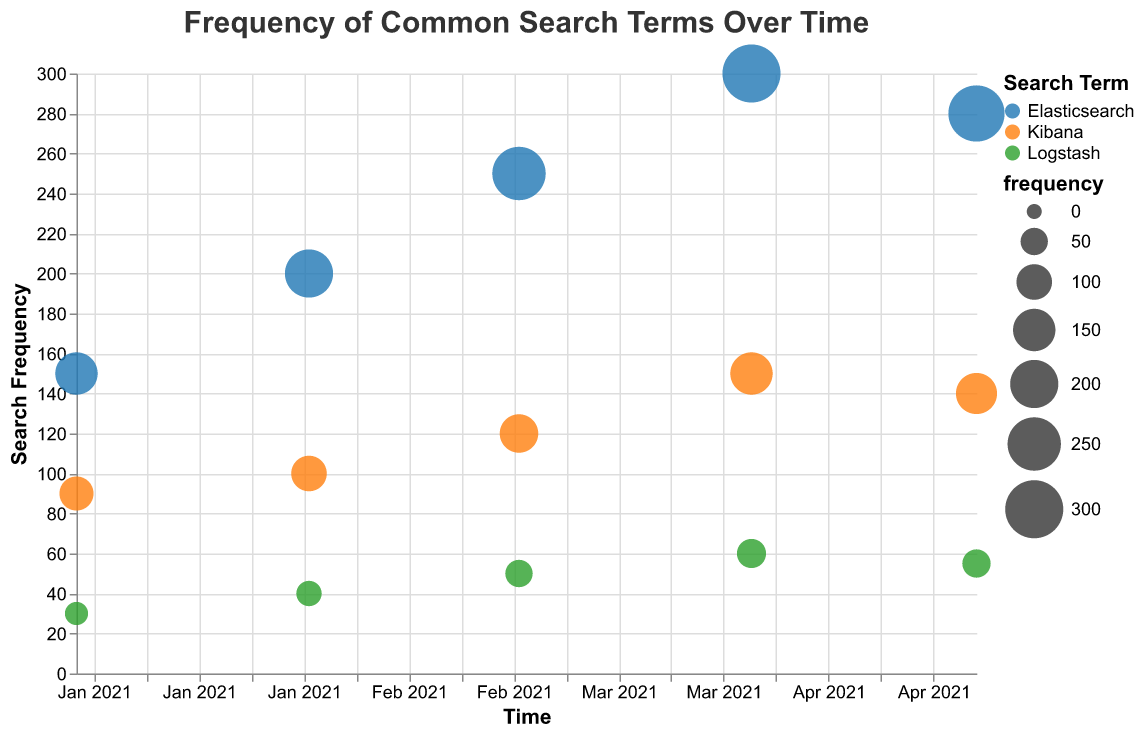What is the title of the figure? The title is located at the top of the figure and clearly labeled. It summarizes the content of the chart.
Answer: Frequency of Common Search Terms Over Time What is the color assigned to the term "Elasticsearch"? The color for each search term is indicated in the legend at the right side of the figure.
Answer: Blue Which search term has the highest frequency in April 2021? By examining the size of the bubbles and their vertical position on the y-axis, "Elasticsearch" has the largest circle and highest position in April 2021.
Answer: Elasticsearch In which month did "Logstash" have the lowest frequency and what was it? By scanning all months and identifying the smallest bubble for "Logstash", in January 2021, the frequency is 30.
Answer: January 2021, 30 How does the trend of "Kibana" differ from "Elasticsearch" over time? Look at the changes in the sizes of the bubbles and their positions across months for both terms. "Elasticsearch" shows a general increase, whereas "Kibana" also increases but at a slower rate and with smaller bubble sizes.
Answer: Elasticsearch increases more significantly over time than Kibana What are the average frequencies of "Logstash" over the five months? Sum the frequencies for "Logstash" over all months and divide by five: (30 + 40 + 50 + 60 + 55) / 5.
Answer: 47 Which term experienced the highest increase in frequency from January to May 2021? Calculate the difference in frequency between May and January for each term: Elasticsearch (280-150), Kibana (140-90), and Logstash (55-30). Compare the increases.
Answer: Elasticsearch Between February and March 2021, which term had the largest growth in frequency? Calculate the difference in frequency from February to March for each term: Elasticsearch (250-200), Kibana (120-100), Logstash (50-40). Compare these values.
Answer: Elasticsearch Identify the month and term with the smallest bubble on the chart. The smallest bubble indicates the lowest frequency, visually identified as "Logstash" in January 2021.
Answer: January 2021, Logstash 